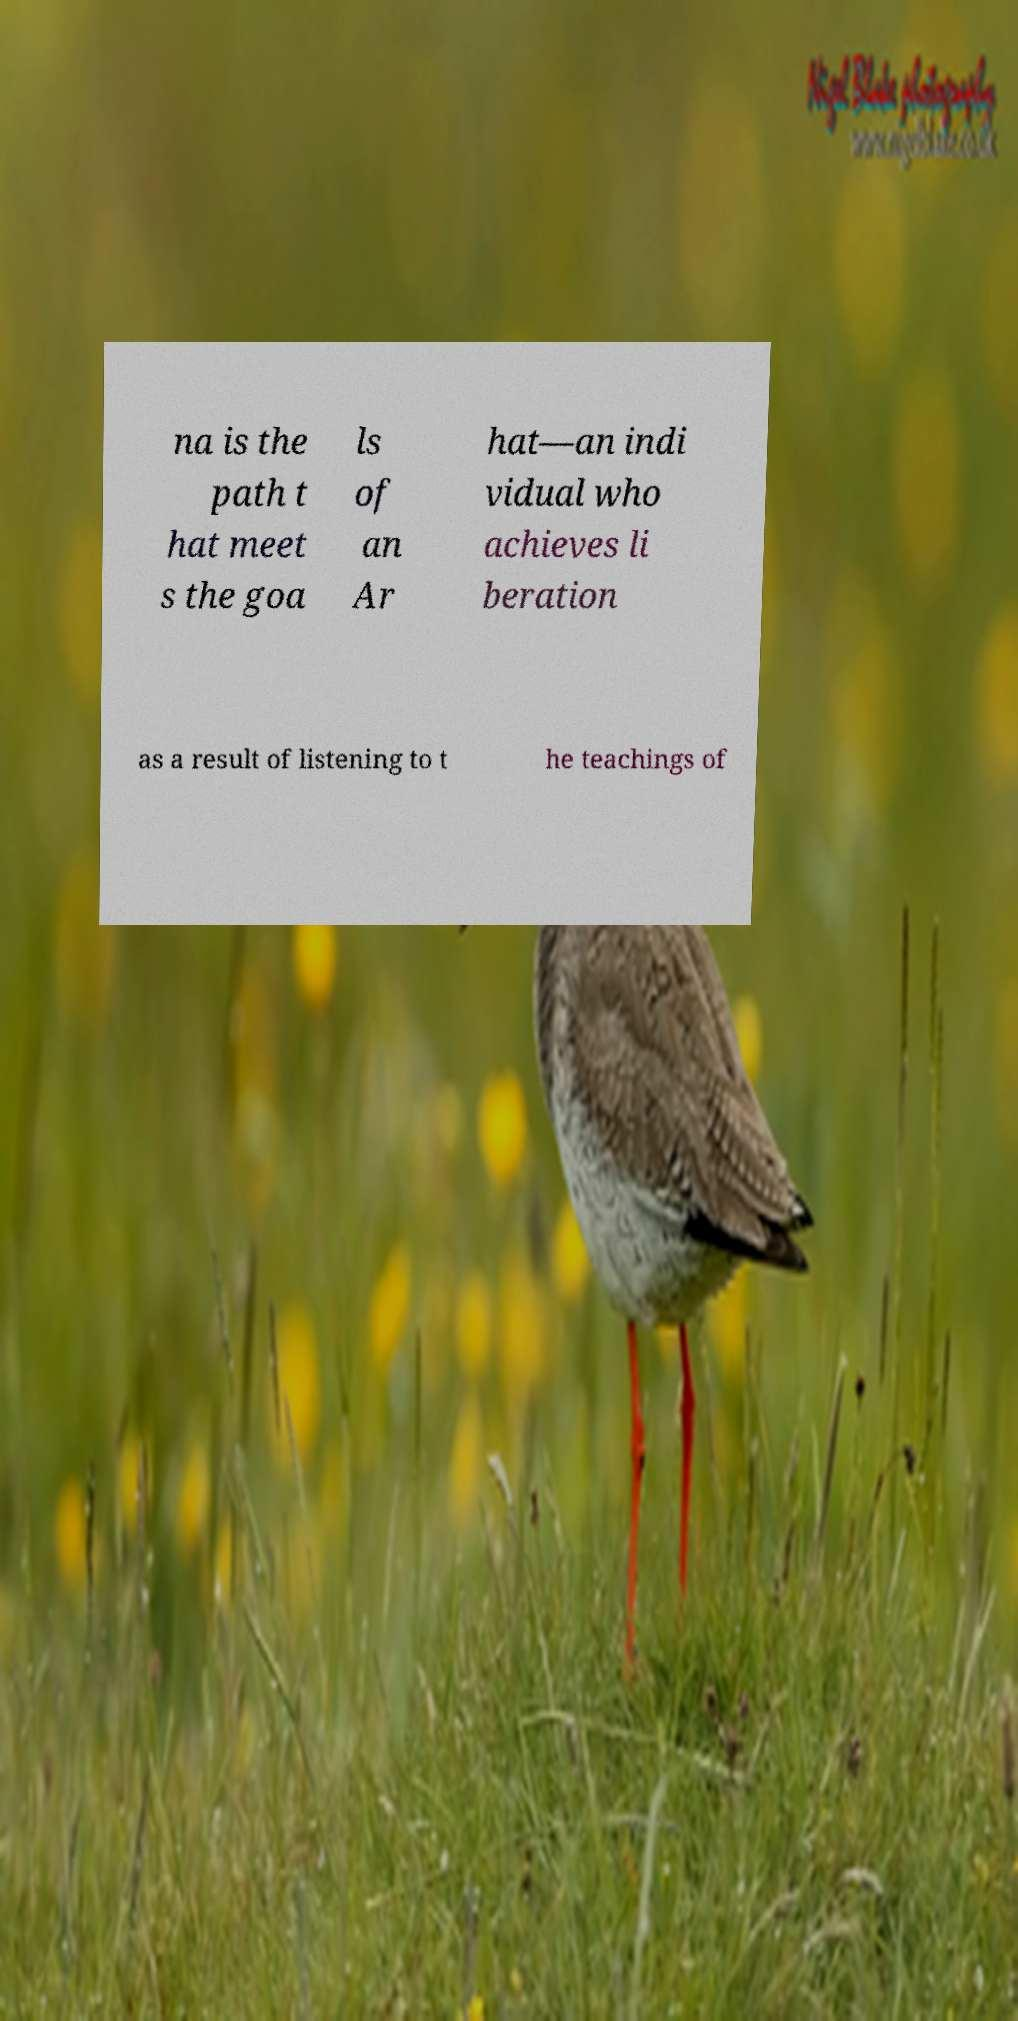Can you accurately transcribe the text from the provided image for me? na is the path t hat meet s the goa ls of an Ar hat—an indi vidual who achieves li beration as a result of listening to t he teachings of 